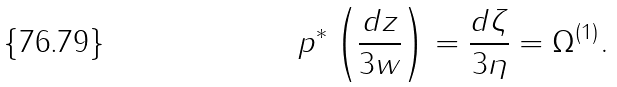Convert formula to latex. <formula><loc_0><loc_0><loc_500><loc_500>p ^ { * } \left ( \frac { d z } { 3 w } \right ) = \frac { d \zeta } { 3 \eta } = \Omega ^ { ( 1 ) } .</formula> 